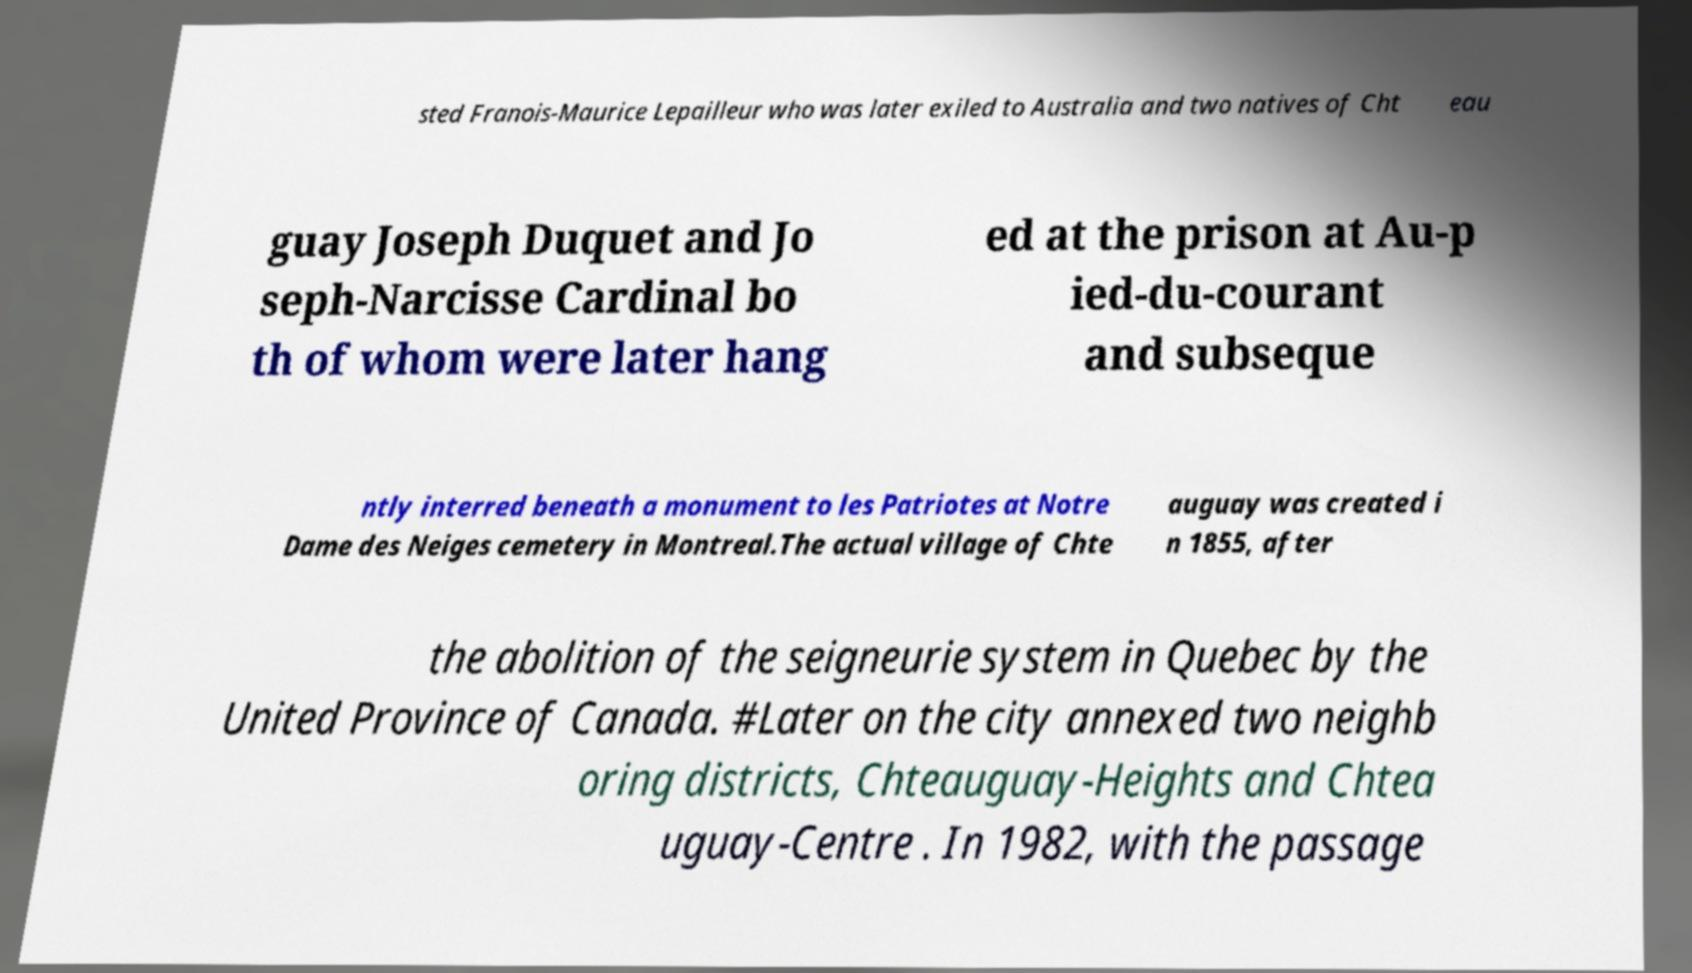Could you extract and type out the text from this image? sted Franois-Maurice Lepailleur who was later exiled to Australia and two natives of Cht eau guay Joseph Duquet and Jo seph-Narcisse Cardinal bo th of whom were later hang ed at the prison at Au-p ied-du-courant and subseque ntly interred beneath a monument to les Patriotes at Notre Dame des Neiges cemetery in Montreal.The actual village of Chte auguay was created i n 1855, after the abolition of the seigneurie system in Quebec by the United Province of Canada. #Later on the city annexed two neighb oring districts, Chteauguay-Heights and Chtea uguay-Centre . In 1982, with the passage 